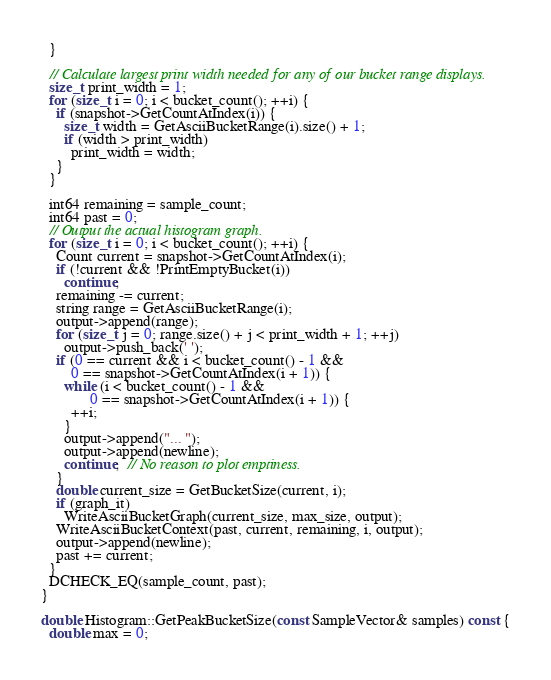Convert code to text. <code><loc_0><loc_0><loc_500><loc_500><_C++_>  }

  // Calculate largest print width needed for any of our bucket range displays.
  size_t print_width = 1;
  for (size_t i = 0; i < bucket_count(); ++i) {
    if (snapshot->GetCountAtIndex(i)) {
      size_t width = GetAsciiBucketRange(i).size() + 1;
      if (width > print_width)
        print_width = width;
    }
  }

  int64 remaining = sample_count;
  int64 past = 0;
  // Output the actual histogram graph.
  for (size_t i = 0; i < bucket_count(); ++i) {
    Count current = snapshot->GetCountAtIndex(i);
    if (!current && !PrintEmptyBucket(i))
      continue;
    remaining -= current;
    string range = GetAsciiBucketRange(i);
    output->append(range);
    for (size_t j = 0; range.size() + j < print_width + 1; ++j)
      output->push_back(' ');
    if (0 == current && i < bucket_count() - 1 &&
        0 == snapshot->GetCountAtIndex(i + 1)) {
      while (i < bucket_count() - 1 &&
             0 == snapshot->GetCountAtIndex(i + 1)) {
        ++i;
      }
      output->append("... ");
      output->append(newline);
      continue;  // No reason to plot emptiness.
    }
    double current_size = GetBucketSize(current, i);
    if (graph_it)
      WriteAsciiBucketGraph(current_size, max_size, output);
    WriteAsciiBucketContext(past, current, remaining, i, output);
    output->append(newline);
    past += current;
  }
  DCHECK_EQ(sample_count, past);
}

double Histogram::GetPeakBucketSize(const SampleVector& samples) const {
  double max = 0;</code> 